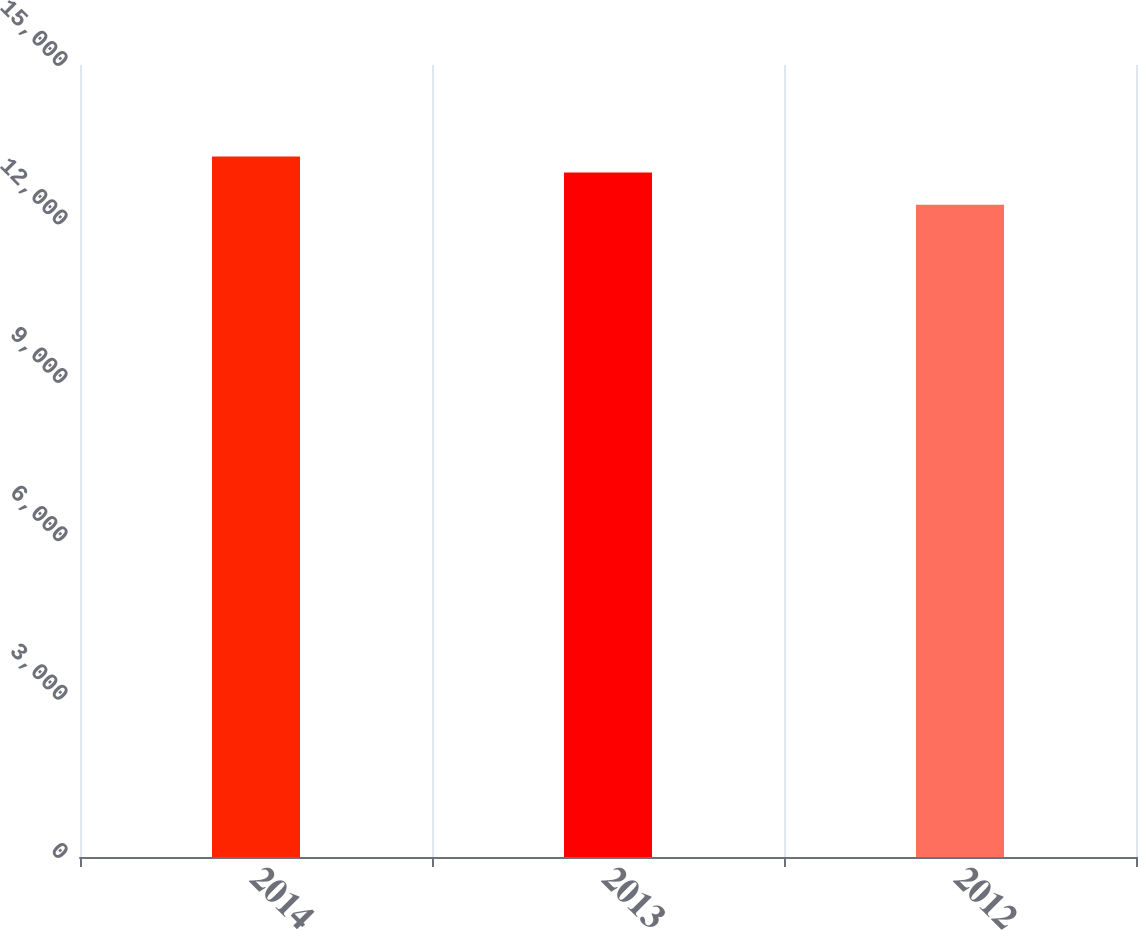Convert chart to OTSL. <chart><loc_0><loc_0><loc_500><loc_500><bar_chart><fcel>2014<fcel>2013<fcel>2012<nl><fcel>13266<fcel>12962<fcel>12353<nl></chart> 